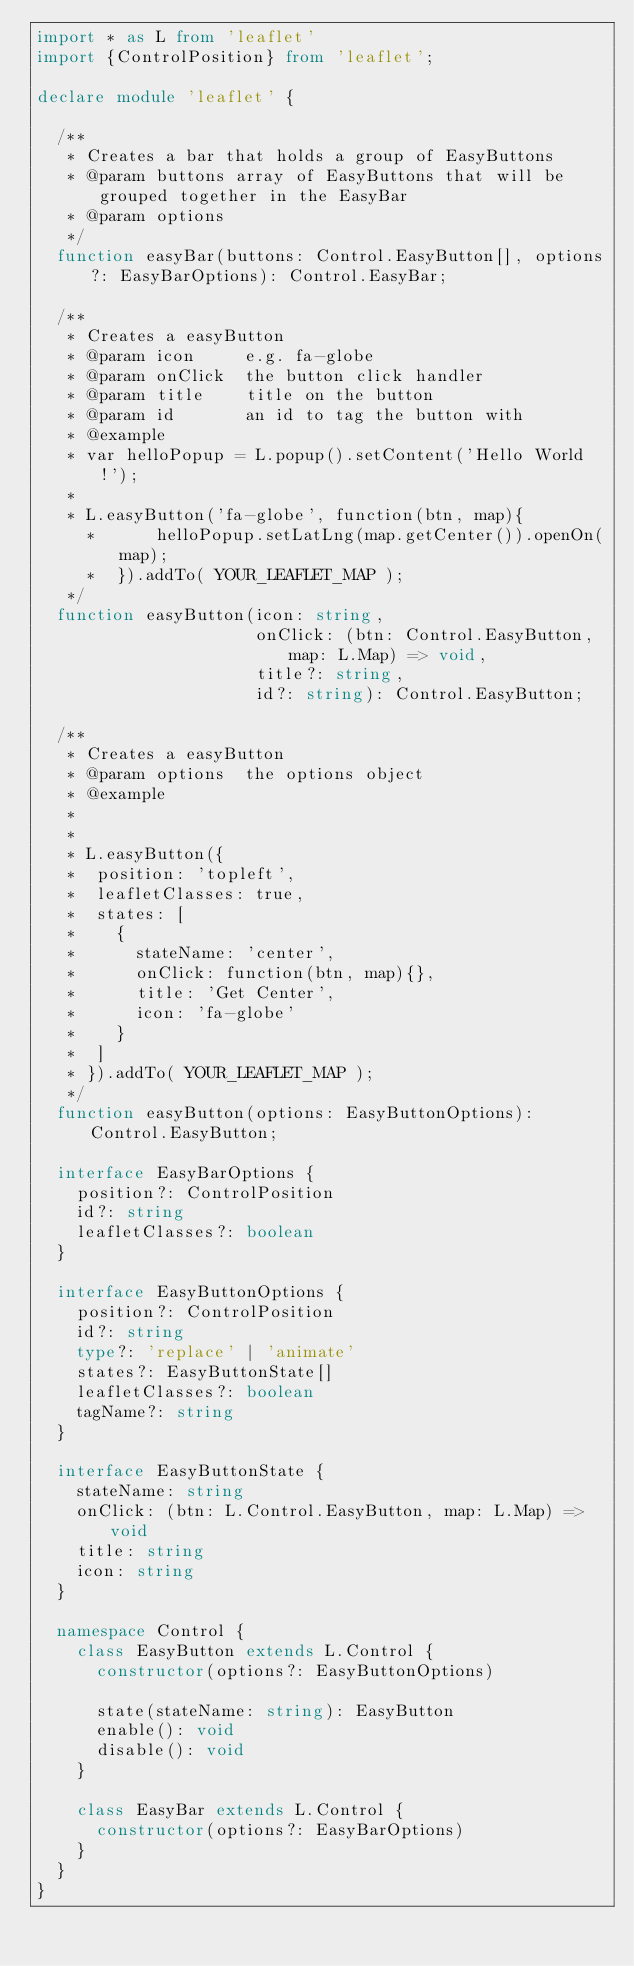<code> <loc_0><loc_0><loc_500><loc_500><_TypeScript_>import * as L from 'leaflet'
import {ControlPosition} from 'leaflet';

declare module 'leaflet' {

  /**
   * Creates a bar that holds a group of EasyButtons
   * @param buttons array of EasyButtons that will be grouped together in the EasyBar
   * @param options
   */
  function easyBar(buttons: Control.EasyButton[], options?: EasyBarOptions): Control.EasyBar;

  /**
   * Creates a easyButton
   * @param icon     e.g. fa-globe
   * @param onClick  the button click handler
   * @param title    title on the button
   * @param id       an id to tag the button with
   * @example
   * var helloPopup = L.popup().setContent('Hello World!');
   *
   * L.easyButton('fa-globe', function(btn, map){
     *      helloPopup.setLatLng(map.getCenter()).openOn(map);
     *  }).addTo( YOUR_LEAFLET_MAP );
   */
  function easyButton(icon: string,
                      onClick: (btn: Control.EasyButton, map: L.Map) => void,
                      title?: string,
                      id?: string): Control.EasyButton;

  /**
   * Creates a easyButton
   * @param options  the options object
   * @example
   *
   *
   * L.easyButton({
   *  position: 'topleft',
   *  leafletClasses: true,
   *  states: [
   *    {
   *      stateName: 'center',
   *      onClick: function(btn, map){},
   *      title: 'Get Center',
   *      icon: 'fa-globe'
   *    }
   *  ]
   * }).addTo( YOUR_LEAFLET_MAP );
   */
  function easyButton(options: EasyButtonOptions): Control.EasyButton;

  interface EasyBarOptions {
    position?: ControlPosition
    id?: string
    leafletClasses?: boolean
  }

  interface EasyButtonOptions {
    position?: ControlPosition
    id?: string
    type?: 'replace' | 'animate'
    states?: EasyButtonState[]
    leafletClasses?: boolean
    tagName?: string
  }

  interface EasyButtonState {
    stateName: string
    onClick: (btn: L.Control.EasyButton, map: L.Map) => void
    title: string
    icon: string
  }

  namespace Control {
    class EasyButton extends L.Control {
      constructor(options?: EasyButtonOptions)

      state(stateName: string): EasyButton
      enable(): void
      disable(): void
    }

    class EasyBar extends L.Control {
      constructor(options?: EasyBarOptions)
    }
  }
}
</code> 